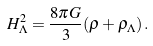<formula> <loc_0><loc_0><loc_500><loc_500>H _ { \Lambda } ^ { 2 } = \frac { 8 \pi G } { 3 } ( \rho + \rho _ { \Lambda } ) \, .</formula> 